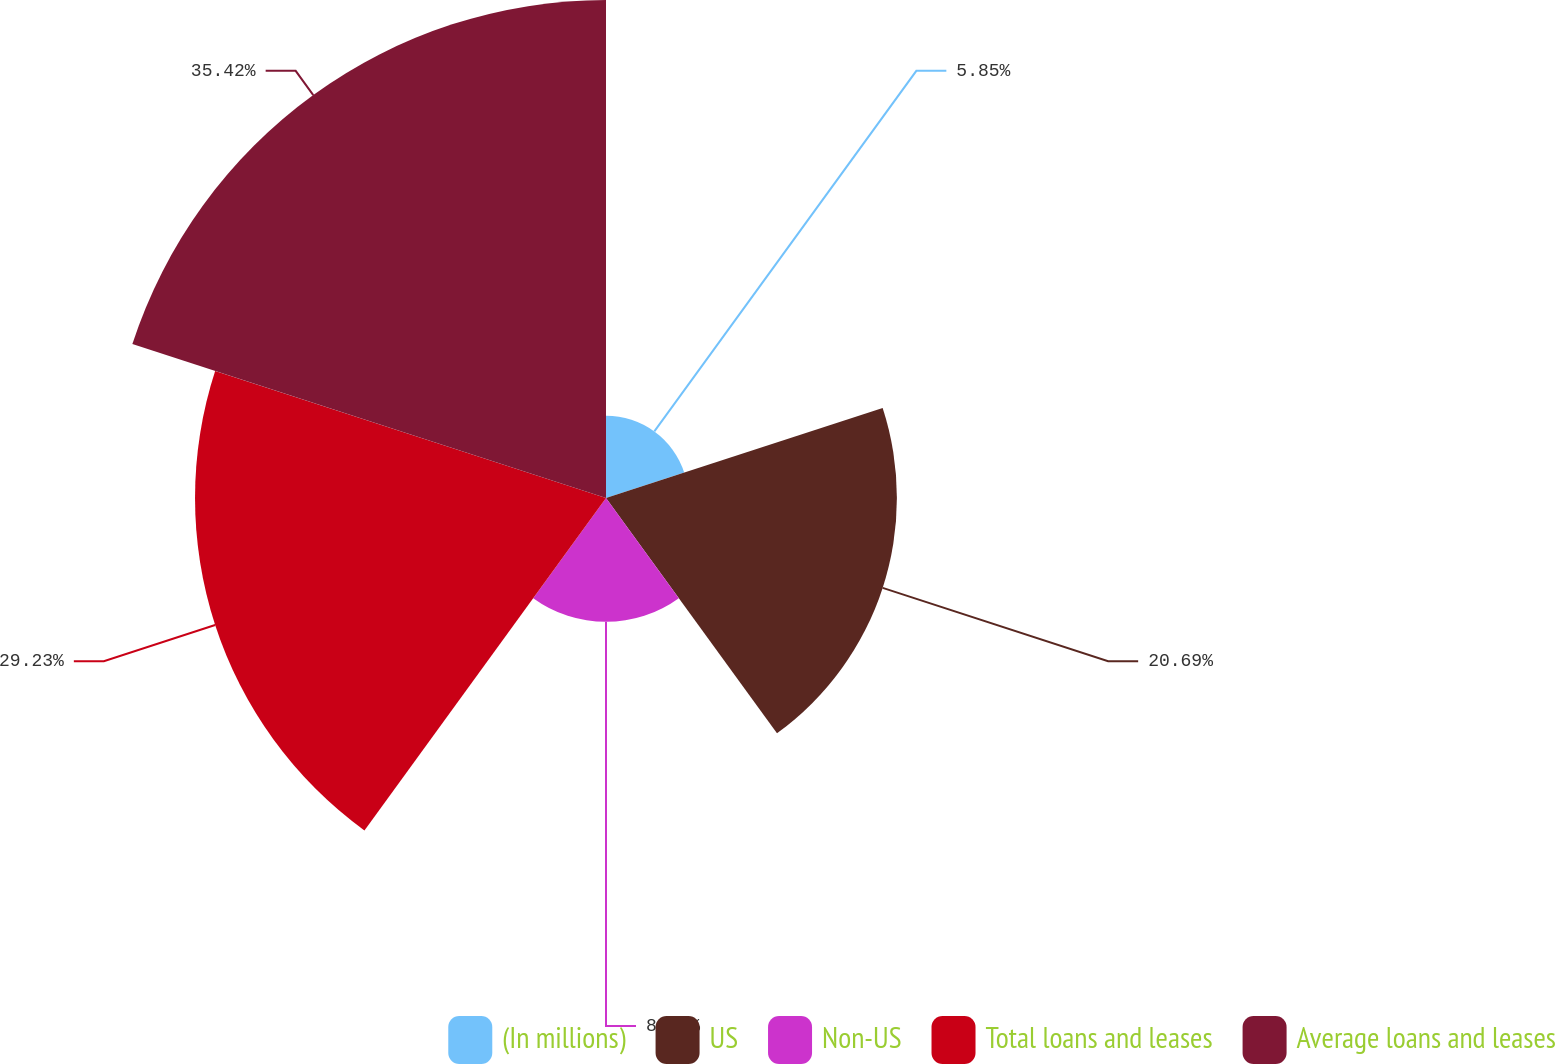Convert chart to OTSL. <chart><loc_0><loc_0><loc_500><loc_500><pie_chart><fcel>(In millions)<fcel>US<fcel>Non-US<fcel>Total loans and leases<fcel>Average loans and leases<nl><fcel>5.85%<fcel>20.69%<fcel>8.81%<fcel>29.23%<fcel>35.42%<nl></chart> 